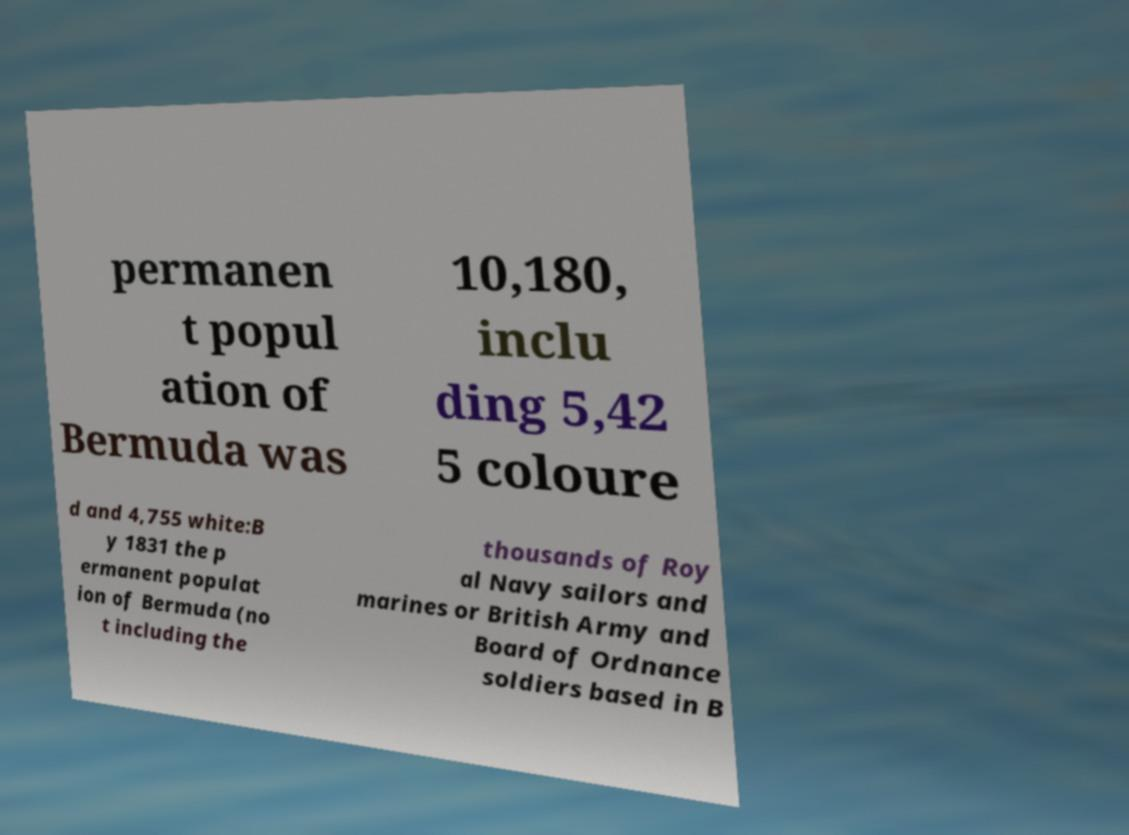For documentation purposes, I need the text within this image transcribed. Could you provide that? permanen t popul ation of Bermuda was 10,180, inclu ding 5,42 5 coloure d and 4,755 white:B y 1831 the p ermanent populat ion of Bermuda (no t including the thousands of Roy al Navy sailors and marines or British Army and Board of Ordnance soldiers based in B 